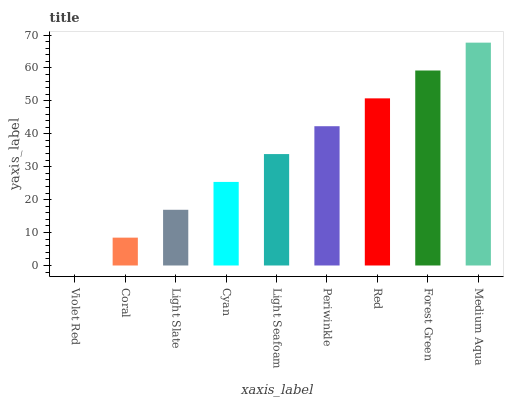Is Violet Red the minimum?
Answer yes or no. Yes. Is Medium Aqua the maximum?
Answer yes or no. Yes. Is Coral the minimum?
Answer yes or no. No. Is Coral the maximum?
Answer yes or no. No. Is Coral greater than Violet Red?
Answer yes or no. Yes. Is Violet Red less than Coral?
Answer yes or no. Yes. Is Violet Red greater than Coral?
Answer yes or no. No. Is Coral less than Violet Red?
Answer yes or no. No. Is Light Seafoam the high median?
Answer yes or no. Yes. Is Light Seafoam the low median?
Answer yes or no. Yes. Is Medium Aqua the high median?
Answer yes or no. No. Is Red the low median?
Answer yes or no. No. 